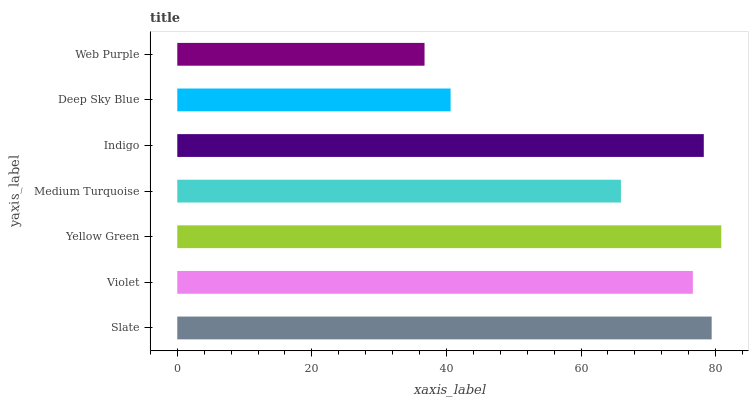Is Web Purple the minimum?
Answer yes or no. Yes. Is Yellow Green the maximum?
Answer yes or no. Yes. Is Violet the minimum?
Answer yes or no. No. Is Violet the maximum?
Answer yes or no. No. Is Slate greater than Violet?
Answer yes or no. Yes. Is Violet less than Slate?
Answer yes or no. Yes. Is Violet greater than Slate?
Answer yes or no. No. Is Slate less than Violet?
Answer yes or no. No. Is Violet the high median?
Answer yes or no. Yes. Is Violet the low median?
Answer yes or no. Yes. Is Deep Sky Blue the high median?
Answer yes or no. No. Is Slate the low median?
Answer yes or no. No. 